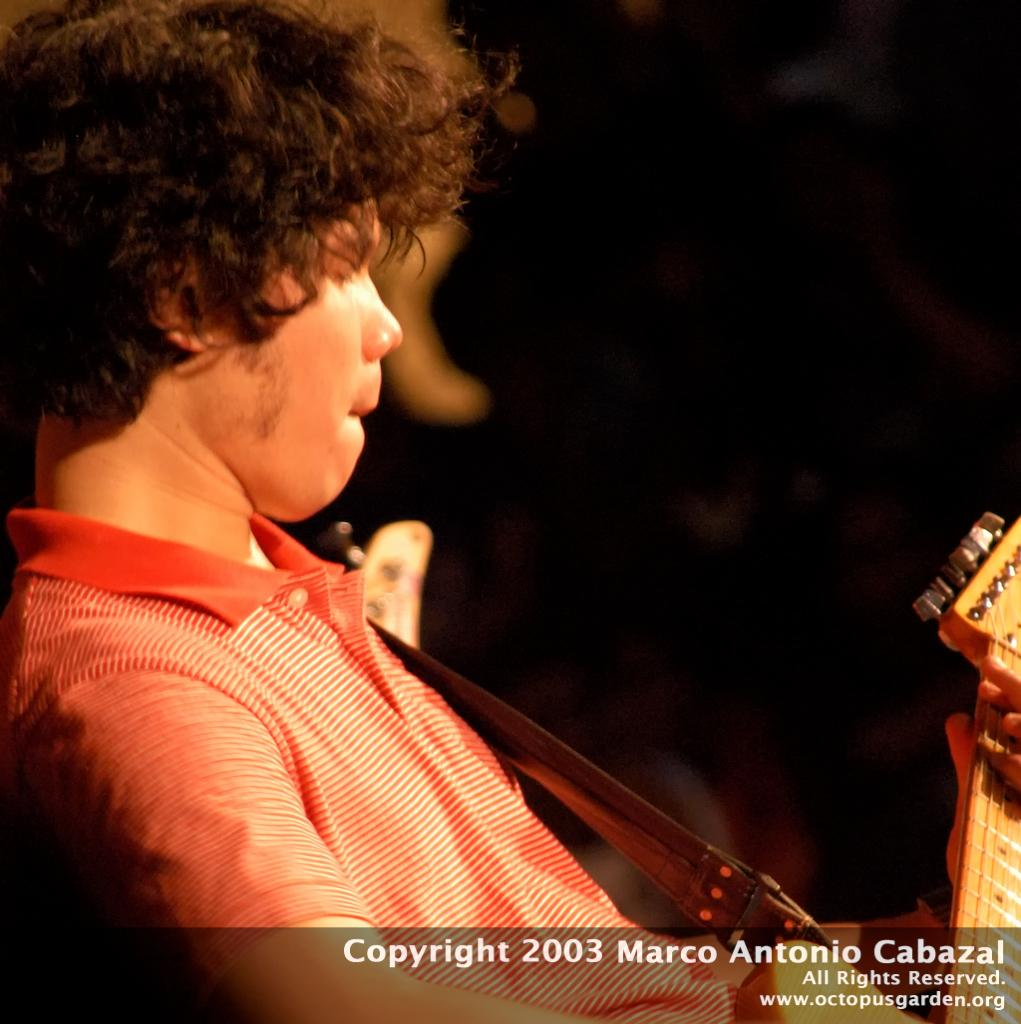What is the main subject of the image? There is a person in the image. What is the person doing in the image? The person is playing a guitar. Is there any text present in the image? Yes, there is some text in the bottom of the image. How would you describe the overall appearance of the image? The background of the image is dark. How many crayons are being used by the men in the image? There are no men or crayons present in the image. What day of the week is depicted in the image? The image does not depict a specific day of the week. 